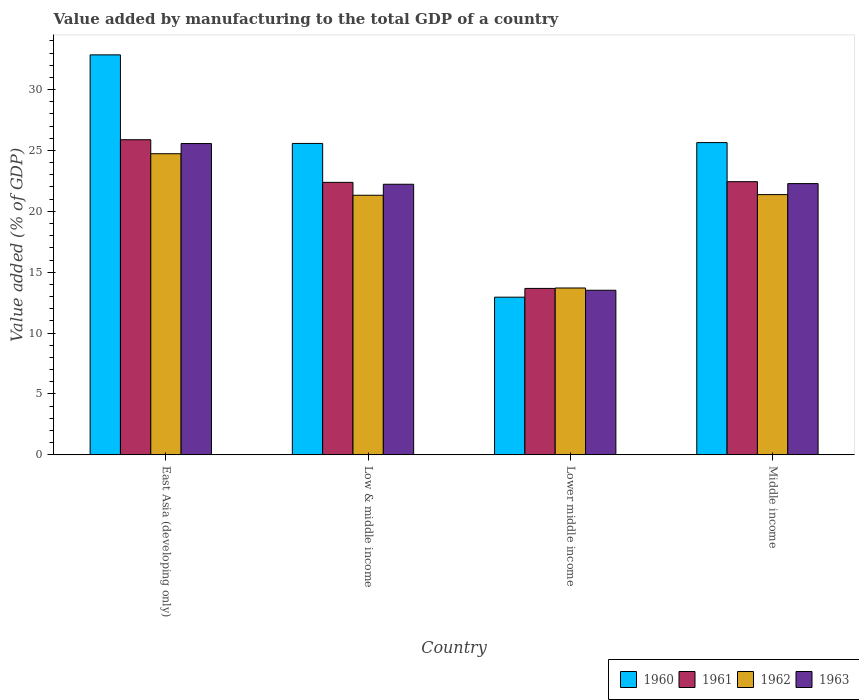How many different coloured bars are there?
Ensure brevity in your answer.  4. How many groups of bars are there?
Your response must be concise. 4. Are the number of bars per tick equal to the number of legend labels?
Give a very brief answer. Yes. What is the label of the 2nd group of bars from the left?
Provide a succinct answer. Low & middle income. In how many cases, is the number of bars for a given country not equal to the number of legend labels?
Your response must be concise. 0. What is the value added by manufacturing to the total GDP in 1960 in Lower middle income?
Provide a succinct answer. 12.95. Across all countries, what is the maximum value added by manufacturing to the total GDP in 1963?
Offer a terse response. 25.57. Across all countries, what is the minimum value added by manufacturing to the total GDP in 1961?
Your response must be concise. 13.67. In which country was the value added by manufacturing to the total GDP in 1963 maximum?
Your response must be concise. East Asia (developing only). In which country was the value added by manufacturing to the total GDP in 1960 minimum?
Make the answer very short. Lower middle income. What is the total value added by manufacturing to the total GDP in 1963 in the graph?
Provide a succinct answer. 83.59. What is the difference between the value added by manufacturing to the total GDP in 1963 in East Asia (developing only) and that in Lower middle income?
Your answer should be compact. 12.05. What is the difference between the value added by manufacturing to the total GDP in 1960 in East Asia (developing only) and the value added by manufacturing to the total GDP in 1963 in Lower middle income?
Keep it short and to the point. 19.34. What is the average value added by manufacturing to the total GDP in 1962 per country?
Provide a succinct answer. 20.28. What is the difference between the value added by manufacturing to the total GDP of/in 1961 and value added by manufacturing to the total GDP of/in 1960 in Middle income?
Your answer should be compact. -3.21. In how many countries, is the value added by manufacturing to the total GDP in 1960 greater than 5 %?
Your answer should be compact. 4. What is the ratio of the value added by manufacturing to the total GDP in 1962 in Low & middle income to that in Lower middle income?
Offer a very short reply. 1.56. What is the difference between the highest and the second highest value added by manufacturing to the total GDP in 1963?
Your answer should be very brief. 3.29. What is the difference between the highest and the lowest value added by manufacturing to the total GDP in 1963?
Provide a short and direct response. 12.05. In how many countries, is the value added by manufacturing to the total GDP in 1960 greater than the average value added by manufacturing to the total GDP in 1960 taken over all countries?
Your answer should be very brief. 3. Is the sum of the value added by manufacturing to the total GDP in 1962 in Lower middle income and Middle income greater than the maximum value added by manufacturing to the total GDP in 1963 across all countries?
Ensure brevity in your answer.  Yes. What does the 1st bar from the right in Lower middle income represents?
Provide a short and direct response. 1963. Is it the case that in every country, the sum of the value added by manufacturing to the total GDP in 1962 and value added by manufacturing to the total GDP in 1963 is greater than the value added by manufacturing to the total GDP in 1961?
Keep it short and to the point. Yes. How many bars are there?
Your answer should be very brief. 16. Are all the bars in the graph horizontal?
Your response must be concise. No. What is the difference between two consecutive major ticks on the Y-axis?
Provide a short and direct response. 5. Are the values on the major ticks of Y-axis written in scientific E-notation?
Provide a short and direct response. No. How many legend labels are there?
Make the answer very short. 4. What is the title of the graph?
Offer a very short reply. Value added by manufacturing to the total GDP of a country. Does "2004" appear as one of the legend labels in the graph?
Keep it short and to the point. No. What is the label or title of the Y-axis?
Make the answer very short. Value added (% of GDP). What is the Value added (% of GDP) of 1960 in East Asia (developing only)?
Offer a very short reply. 32.85. What is the Value added (% of GDP) in 1961 in East Asia (developing only)?
Give a very brief answer. 25.88. What is the Value added (% of GDP) of 1962 in East Asia (developing only)?
Your answer should be compact. 24.73. What is the Value added (% of GDP) of 1963 in East Asia (developing only)?
Provide a short and direct response. 25.57. What is the Value added (% of GDP) of 1960 in Low & middle income?
Your response must be concise. 25.58. What is the Value added (% of GDP) of 1961 in Low & middle income?
Your answer should be compact. 22.38. What is the Value added (% of GDP) of 1962 in Low & middle income?
Provide a succinct answer. 21.32. What is the Value added (% of GDP) in 1963 in Low & middle income?
Offer a very short reply. 22.22. What is the Value added (% of GDP) of 1960 in Lower middle income?
Your answer should be compact. 12.95. What is the Value added (% of GDP) of 1961 in Lower middle income?
Your answer should be very brief. 13.67. What is the Value added (% of GDP) of 1962 in Lower middle income?
Offer a terse response. 13.7. What is the Value added (% of GDP) in 1963 in Lower middle income?
Your answer should be compact. 13.52. What is the Value added (% of GDP) of 1960 in Middle income?
Your response must be concise. 25.65. What is the Value added (% of GDP) of 1961 in Middle income?
Your response must be concise. 22.44. What is the Value added (% of GDP) in 1962 in Middle income?
Offer a terse response. 21.37. What is the Value added (% of GDP) of 1963 in Middle income?
Provide a succinct answer. 22.28. Across all countries, what is the maximum Value added (% of GDP) in 1960?
Your response must be concise. 32.85. Across all countries, what is the maximum Value added (% of GDP) in 1961?
Give a very brief answer. 25.88. Across all countries, what is the maximum Value added (% of GDP) in 1962?
Ensure brevity in your answer.  24.73. Across all countries, what is the maximum Value added (% of GDP) in 1963?
Provide a succinct answer. 25.57. Across all countries, what is the minimum Value added (% of GDP) in 1960?
Your answer should be very brief. 12.95. Across all countries, what is the minimum Value added (% of GDP) of 1961?
Your response must be concise. 13.67. Across all countries, what is the minimum Value added (% of GDP) of 1962?
Your answer should be very brief. 13.7. Across all countries, what is the minimum Value added (% of GDP) of 1963?
Make the answer very short. 13.52. What is the total Value added (% of GDP) of 1960 in the graph?
Ensure brevity in your answer.  97.03. What is the total Value added (% of GDP) in 1961 in the graph?
Your answer should be compact. 84.37. What is the total Value added (% of GDP) in 1962 in the graph?
Offer a terse response. 81.13. What is the total Value added (% of GDP) in 1963 in the graph?
Provide a succinct answer. 83.59. What is the difference between the Value added (% of GDP) in 1960 in East Asia (developing only) and that in Low & middle income?
Offer a terse response. 7.27. What is the difference between the Value added (% of GDP) of 1961 in East Asia (developing only) and that in Low & middle income?
Provide a succinct answer. 3.5. What is the difference between the Value added (% of GDP) of 1962 in East Asia (developing only) and that in Low & middle income?
Offer a very short reply. 3.41. What is the difference between the Value added (% of GDP) in 1963 in East Asia (developing only) and that in Low & middle income?
Make the answer very short. 3.34. What is the difference between the Value added (% of GDP) of 1960 in East Asia (developing only) and that in Lower middle income?
Provide a short and direct response. 19.91. What is the difference between the Value added (% of GDP) of 1961 in East Asia (developing only) and that in Lower middle income?
Provide a short and direct response. 12.21. What is the difference between the Value added (% of GDP) of 1962 in East Asia (developing only) and that in Lower middle income?
Your answer should be compact. 11.03. What is the difference between the Value added (% of GDP) of 1963 in East Asia (developing only) and that in Lower middle income?
Your answer should be very brief. 12.05. What is the difference between the Value added (% of GDP) of 1960 in East Asia (developing only) and that in Middle income?
Offer a terse response. 7.21. What is the difference between the Value added (% of GDP) of 1961 in East Asia (developing only) and that in Middle income?
Offer a terse response. 3.45. What is the difference between the Value added (% of GDP) in 1962 in East Asia (developing only) and that in Middle income?
Ensure brevity in your answer.  3.36. What is the difference between the Value added (% of GDP) in 1963 in East Asia (developing only) and that in Middle income?
Ensure brevity in your answer.  3.29. What is the difference between the Value added (% of GDP) in 1960 in Low & middle income and that in Lower middle income?
Give a very brief answer. 12.63. What is the difference between the Value added (% of GDP) of 1961 in Low & middle income and that in Lower middle income?
Provide a short and direct response. 8.71. What is the difference between the Value added (% of GDP) in 1962 in Low & middle income and that in Lower middle income?
Provide a succinct answer. 7.62. What is the difference between the Value added (% of GDP) in 1963 in Low & middle income and that in Lower middle income?
Ensure brevity in your answer.  8.71. What is the difference between the Value added (% of GDP) in 1960 in Low & middle income and that in Middle income?
Your response must be concise. -0.07. What is the difference between the Value added (% of GDP) of 1961 in Low & middle income and that in Middle income?
Provide a short and direct response. -0.06. What is the difference between the Value added (% of GDP) in 1962 in Low & middle income and that in Middle income?
Provide a succinct answer. -0.05. What is the difference between the Value added (% of GDP) of 1963 in Low & middle income and that in Middle income?
Your response must be concise. -0.05. What is the difference between the Value added (% of GDP) of 1960 in Lower middle income and that in Middle income?
Keep it short and to the point. -12.7. What is the difference between the Value added (% of GDP) of 1961 in Lower middle income and that in Middle income?
Offer a very short reply. -8.77. What is the difference between the Value added (% of GDP) in 1962 in Lower middle income and that in Middle income?
Keep it short and to the point. -7.67. What is the difference between the Value added (% of GDP) in 1963 in Lower middle income and that in Middle income?
Give a very brief answer. -8.76. What is the difference between the Value added (% of GDP) of 1960 in East Asia (developing only) and the Value added (% of GDP) of 1961 in Low & middle income?
Give a very brief answer. 10.47. What is the difference between the Value added (% of GDP) in 1960 in East Asia (developing only) and the Value added (% of GDP) in 1962 in Low & middle income?
Make the answer very short. 11.53. What is the difference between the Value added (% of GDP) of 1960 in East Asia (developing only) and the Value added (% of GDP) of 1963 in Low & middle income?
Ensure brevity in your answer.  10.63. What is the difference between the Value added (% of GDP) in 1961 in East Asia (developing only) and the Value added (% of GDP) in 1962 in Low & middle income?
Ensure brevity in your answer.  4.56. What is the difference between the Value added (% of GDP) of 1961 in East Asia (developing only) and the Value added (% of GDP) of 1963 in Low & middle income?
Your answer should be very brief. 3.66. What is the difference between the Value added (% of GDP) of 1962 in East Asia (developing only) and the Value added (% of GDP) of 1963 in Low & middle income?
Provide a succinct answer. 2.51. What is the difference between the Value added (% of GDP) in 1960 in East Asia (developing only) and the Value added (% of GDP) in 1961 in Lower middle income?
Keep it short and to the point. 19.19. What is the difference between the Value added (% of GDP) in 1960 in East Asia (developing only) and the Value added (% of GDP) in 1962 in Lower middle income?
Give a very brief answer. 19.15. What is the difference between the Value added (% of GDP) in 1960 in East Asia (developing only) and the Value added (% of GDP) in 1963 in Lower middle income?
Keep it short and to the point. 19.34. What is the difference between the Value added (% of GDP) in 1961 in East Asia (developing only) and the Value added (% of GDP) in 1962 in Lower middle income?
Your response must be concise. 12.18. What is the difference between the Value added (% of GDP) in 1961 in East Asia (developing only) and the Value added (% of GDP) in 1963 in Lower middle income?
Your answer should be very brief. 12.37. What is the difference between the Value added (% of GDP) of 1962 in East Asia (developing only) and the Value added (% of GDP) of 1963 in Lower middle income?
Provide a succinct answer. 11.22. What is the difference between the Value added (% of GDP) of 1960 in East Asia (developing only) and the Value added (% of GDP) of 1961 in Middle income?
Give a very brief answer. 10.42. What is the difference between the Value added (% of GDP) in 1960 in East Asia (developing only) and the Value added (% of GDP) in 1962 in Middle income?
Provide a short and direct response. 11.48. What is the difference between the Value added (% of GDP) of 1960 in East Asia (developing only) and the Value added (% of GDP) of 1963 in Middle income?
Ensure brevity in your answer.  10.58. What is the difference between the Value added (% of GDP) of 1961 in East Asia (developing only) and the Value added (% of GDP) of 1962 in Middle income?
Your answer should be very brief. 4.51. What is the difference between the Value added (% of GDP) in 1961 in East Asia (developing only) and the Value added (% of GDP) in 1963 in Middle income?
Your response must be concise. 3.6. What is the difference between the Value added (% of GDP) in 1962 in East Asia (developing only) and the Value added (% of GDP) in 1963 in Middle income?
Your answer should be compact. 2.45. What is the difference between the Value added (% of GDP) in 1960 in Low & middle income and the Value added (% of GDP) in 1961 in Lower middle income?
Keep it short and to the point. 11.91. What is the difference between the Value added (% of GDP) of 1960 in Low & middle income and the Value added (% of GDP) of 1962 in Lower middle income?
Make the answer very short. 11.88. What is the difference between the Value added (% of GDP) of 1960 in Low & middle income and the Value added (% of GDP) of 1963 in Lower middle income?
Your answer should be very brief. 12.06. What is the difference between the Value added (% of GDP) in 1961 in Low & middle income and the Value added (% of GDP) in 1962 in Lower middle income?
Offer a very short reply. 8.68. What is the difference between the Value added (% of GDP) in 1961 in Low & middle income and the Value added (% of GDP) in 1963 in Lower middle income?
Offer a terse response. 8.86. What is the difference between the Value added (% of GDP) of 1962 in Low & middle income and the Value added (% of GDP) of 1963 in Lower middle income?
Give a very brief answer. 7.8. What is the difference between the Value added (% of GDP) of 1960 in Low & middle income and the Value added (% of GDP) of 1961 in Middle income?
Your answer should be compact. 3.14. What is the difference between the Value added (% of GDP) in 1960 in Low & middle income and the Value added (% of GDP) in 1962 in Middle income?
Keep it short and to the point. 4.21. What is the difference between the Value added (% of GDP) of 1960 in Low & middle income and the Value added (% of GDP) of 1963 in Middle income?
Offer a very short reply. 3.3. What is the difference between the Value added (% of GDP) of 1961 in Low & middle income and the Value added (% of GDP) of 1962 in Middle income?
Your answer should be very brief. 1.01. What is the difference between the Value added (% of GDP) of 1961 in Low & middle income and the Value added (% of GDP) of 1963 in Middle income?
Offer a terse response. 0.1. What is the difference between the Value added (% of GDP) of 1962 in Low & middle income and the Value added (% of GDP) of 1963 in Middle income?
Your answer should be compact. -0.96. What is the difference between the Value added (% of GDP) of 1960 in Lower middle income and the Value added (% of GDP) of 1961 in Middle income?
Provide a short and direct response. -9.49. What is the difference between the Value added (% of GDP) in 1960 in Lower middle income and the Value added (% of GDP) in 1962 in Middle income?
Provide a succinct answer. -8.43. What is the difference between the Value added (% of GDP) in 1960 in Lower middle income and the Value added (% of GDP) in 1963 in Middle income?
Offer a terse response. -9.33. What is the difference between the Value added (% of GDP) of 1961 in Lower middle income and the Value added (% of GDP) of 1962 in Middle income?
Your answer should be very brief. -7.71. What is the difference between the Value added (% of GDP) of 1961 in Lower middle income and the Value added (% of GDP) of 1963 in Middle income?
Ensure brevity in your answer.  -8.61. What is the difference between the Value added (% of GDP) of 1962 in Lower middle income and the Value added (% of GDP) of 1963 in Middle income?
Provide a short and direct response. -8.57. What is the average Value added (% of GDP) in 1960 per country?
Your answer should be compact. 24.26. What is the average Value added (% of GDP) of 1961 per country?
Your answer should be compact. 21.09. What is the average Value added (% of GDP) in 1962 per country?
Provide a short and direct response. 20.28. What is the average Value added (% of GDP) of 1963 per country?
Your answer should be compact. 20.9. What is the difference between the Value added (% of GDP) in 1960 and Value added (% of GDP) in 1961 in East Asia (developing only)?
Your response must be concise. 6.97. What is the difference between the Value added (% of GDP) in 1960 and Value added (% of GDP) in 1962 in East Asia (developing only)?
Provide a succinct answer. 8.12. What is the difference between the Value added (% of GDP) in 1960 and Value added (% of GDP) in 1963 in East Asia (developing only)?
Your answer should be very brief. 7.28. What is the difference between the Value added (% of GDP) in 1961 and Value added (% of GDP) in 1962 in East Asia (developing only)?
Your answer should be compact. 1.15. What is the difference between the Value added (% of GDP) of 1961 and Value added (% of GDP) of 1963 in East Asia (developing only)?
Your response must be concise. 0.31. What is the difference between the Value added (% of GDP) of 1962 and Value added (% of GDP) of 1963 in East Asia (developing only)?
Your answer should be compact. -0.84. What is the difference between the Value added (% of GDP) in 1960 and Value added (% of GDP) in 1961 in Low & middle income?
Make the answer very short. 3.2. What is the difference between the Value added (% of GDP) in 1960 and Value added (% of GDP) in 1962 in Low & middle income?
Ensure brevity in your answer.  4.26. What is the difference between the Value added (% of GDP) of 1960 and Value added (% of GDP) of 1963 in Low & middle income?
Your answer should be compact. 3.35. What is the difference between the Value added (% of GDP) in 1961 and Value added (% of GDP) in 1962 in Low & middle income?
Provide a short and direct response. 1.06. What is the difference between the Value added (% of GDP) of 1961 and Value added (% of GDP) of 1963 in Low & middle income?
Your answer should be compact. 0.16. What is the difference between the Value added (% of GDP) in 1962 and Value added (% of GDP) in 1963 in Low & middle income?
Offer a very short reply. -0.9. What is the difference between the Value added (% of GDP) of 1960 and Value added (% of GDP) of 1961 in Lower middle income?
Make the answer very short. -0.72. What is the difference between the Value added (% of GDP) in 1960 and Value added (% of GDP) in 1962 in Lower middle income?
Provide a short and direct response. -0.75. What is the difference between the Value added (% of GDP) of 1960 and Value added (% of GDP) of 1963 in Lower middle income?
Make the answer very short. -0.57. What is the difference between the Value added (% of GDP) of 1961 and Value added (% of GDP) of 1962 in Lower middle income?
Your answer should be compact. -0.04. What is the difference between the Value added (% of GDP) in 1961 and Value added (% of GDP) in 1963 in Lower middle income?
Ensure brevity in your answer.  0.15. What is the difference between the Value added (% of GDP) in 1962 and Value added (% of GDP) in 1963 in Lower middle income?
Your answer should be compact. 0.19. What is the difference between the Value added (% of GDP) in 1960 and Value added (% of GDP) in 1961 in Middle income?
Ensure brevity in your answer.  3.21. What is the difference between the Value added (% of GDP) of 1960 and Value added (% of GDP) of 1962 in Middle income?
Offer a very short reply. 4.27. What is the difference between the Value added (% of GDP) of 1960 and Value added (% of GDP) of 1963 in Middle income?
Give a very brief answer. 3.37. What is the difference between the Value added (% of GDP) of 1961 and Value added (% of GDP) of 1962 in Middle income?
Ensure brevity in your answer.  1.06. What is the difference between the Value added (% of GDP) of 1961 and Value added (% of GDP) of 1963 in Middle income?
Give a very brief answer. 0.16. What is the difference between the Value added (% of GDP) in 1962 and Value added (% of GDP) in 1963 in Middle income?
Ensure brevity in your answer.  -0.9. What is the ratio of the Value added (% of GDP) of 1960 in East Asia (developing only) to that in Low & middle income?
Offer a terse response. 1.28. What is the ratio of the Value added (% of GDP) in 1961 in East Asia (developing only) to that in Low & middle income?
Keep it short and to the point. 1.16. What is the ratio of the Value added (% of GDP) of 1962 in East Asia (developing only) to that in Low & middle income?
Provide a succinct answer. 1.16. What is the ratio of the Value added (% of GDP) of 1963 in East Asia (developing only) to that in Low & middle income?
Keep it short and to the point. 1.15. What is the ratio of the Value added (% of GDP) in 1960 in East Asia (developing only) to that in Lower middle income?
Keep it short and to the point. 2.54. What is the ratio of the Value added (% of GDP) of 1961 in East Asia (developing only) to that in Lower middle income?
Ensure brevity in your answer.  1.89. What is the ratio of the Value added (% of GDP) in 1962 in East Asia (developing only) to that in Lower middle income?
Make the answer very short. 1.8. What is the ratio of the Value added (% of GDP) of 1963 in East Asia (developing only) to that in Lower middle income?
Keep it short and to the point. 1.89. What is the ratio of the Value added (% of GDP) of 1960 in East Asia (developing only) to that in Middle income?
Give a very brief answer. 1.28. What is the ratio of the Value added (% of GDP) in 1961 in East Asia (developing only) to that in Middle income?
Your answer should be compact. 1.15. What is the ratio of the Value added (% of GDP) in 1962 in East Asia (developing only) to that in Middle income?
Provide a short and direct response. 1.16. What is the ratio of the Value added (% of GDP) in 1963 in East Asia (developing only) to that in Middle income?
Your answer should be compact. 1.15. What is the ratio of the Value added (% of GDP) in 1960 in Low & middle income to that in Lower middle income?
Ensure brevity in your answer.  1.98. What is the ratio of the Value added (% of GDP) in 1961 in Low & middle income to that in Lower middle income?
Ensure brevity in your answer.  1.64. What is the ratio of the Value added (% of GDP) in 1962 in Low & middle income to that in Lower middle income?
Provide a short and direct response. 1.56. What is the ratio of the Value added (% of GDP) in 1963 in Low & middle income to that in Lower middle income?
Your answer should be very brief. 1.64. What is the ratio of the Value added (% of GDP) in 1960 in Low & middle income to that in Middle income?
Keep it short and to the point. 1. What is the ratio of the Value added (% of GDP) of 1961 in Low & middle income to that in Middle income?
Ensure brevity in your answer.  1. What is the ratio of the Value added (% of GDP) of 1960 in Lower middle income to that in Middle income?
Your answer should be compact. 0.5. What is the ratio of the Value added (% of GDP) in 1961 in Lower middle income to that in Middle income?
Your answer should be very brief. 0.61. What is the ratio of the Value added (% of GDP) of 1962 in Lower middle income to that in Middle income?
Your answer should be very brief. 0.64. What is the ratio of the Value added (% of GDP) of 1963 in Lower middle income to that in Middle income?
Provide a succinct answer. 0.61. What is the difference between the highest and the second highest Value added (% of GDP) of 1960?
Your answer should be compact. 7.21. What is the difference between the highest and the second highest Value added (% of GDP) of 1961?
Offer a terse response. 3.45. What is the difference between the highest and the second highest Value added (% of GDP) in 1962?
Provide a short and direct response. 3.36. What is the difference between the highest and the second highest Value added (% of GDP) in 1963?
Give a very brief answer. 3.29. What is the difference between the highest and the lowest Value added (% of GDP) in 1960?
Make the answer very short. 19.91. What is the difference between the highest and the lowest Value added (% of GDP) in 1961?
Give a very brief answer. 12.21. What is the difference between the highest and the lowest Value added (% of GDP) in 1962?
Ensure brevity in your answer.  11.03. What is the difference between the highest and the lowest Value added (% of GDP) of 1963?
Your response must be concise. 12.05. 